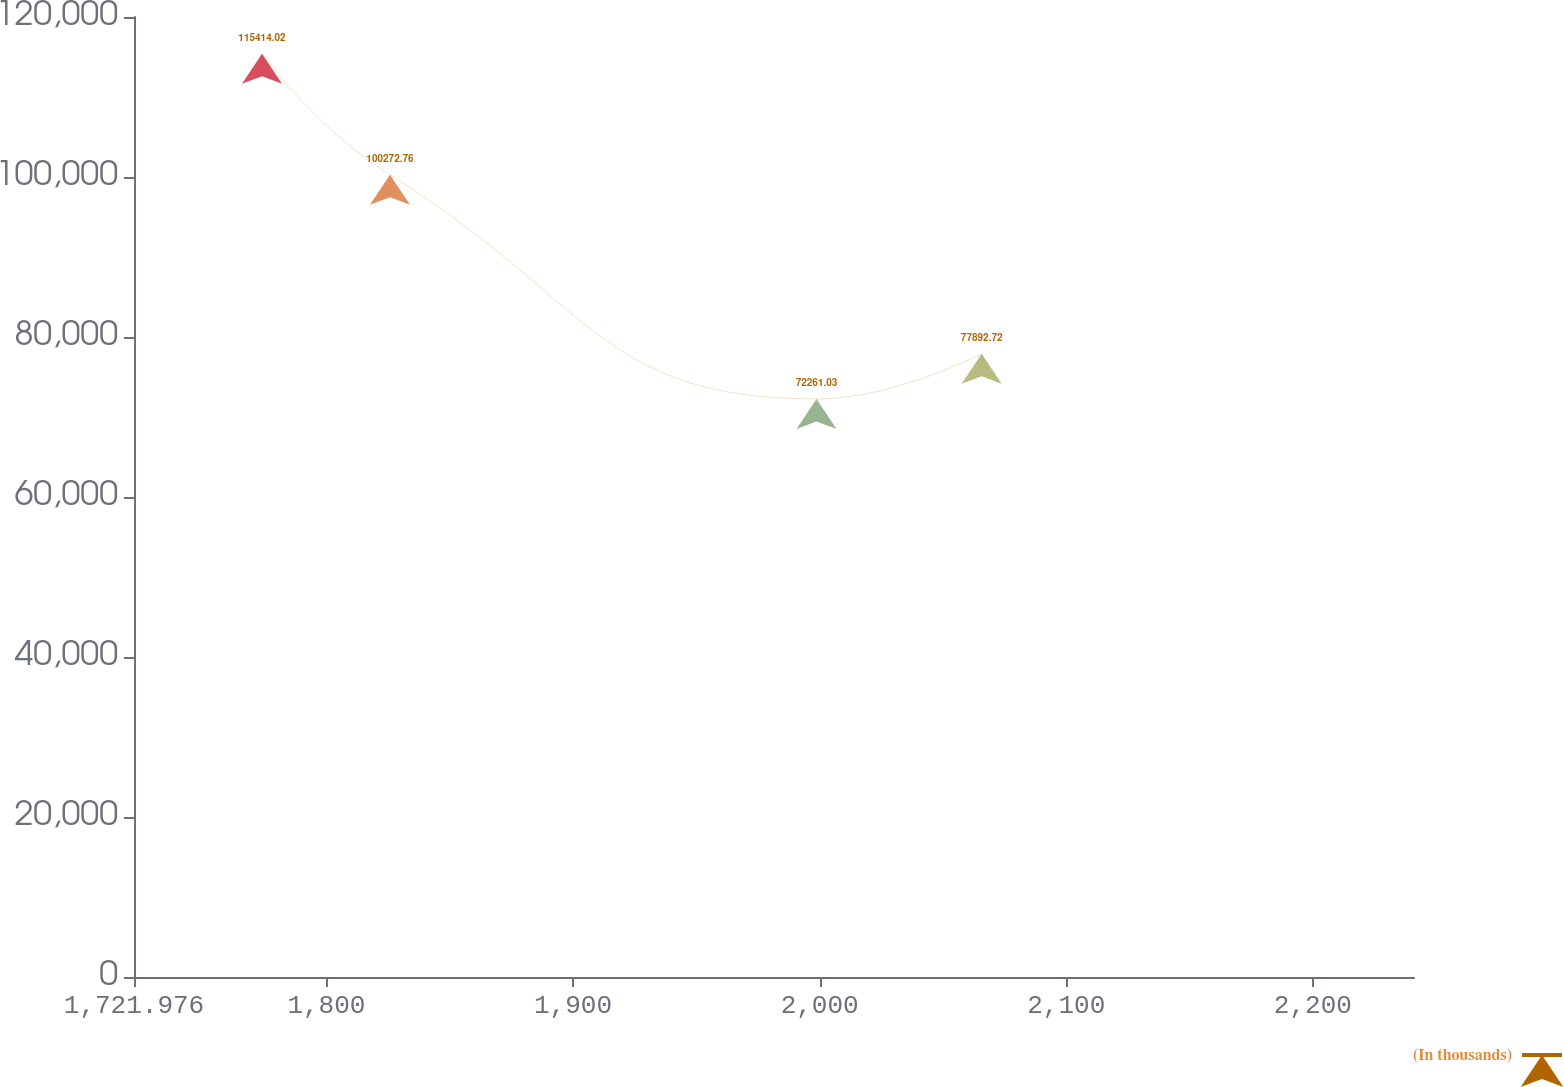Convert chart. <chart><loc_0><loc_0><loc_500><loc_500><line_chart><ecel><fcel>(In thousands)<nl><fcel>1773.88<fcel>115414<nl><fcel>1825.78<fcel>100273<nl><fcel>1998.73<fcel>72261<nl><fcel>2065.71<fcel>77892.7<nl><fcel>2292.92<fcel>59097.2<nl></chart> 